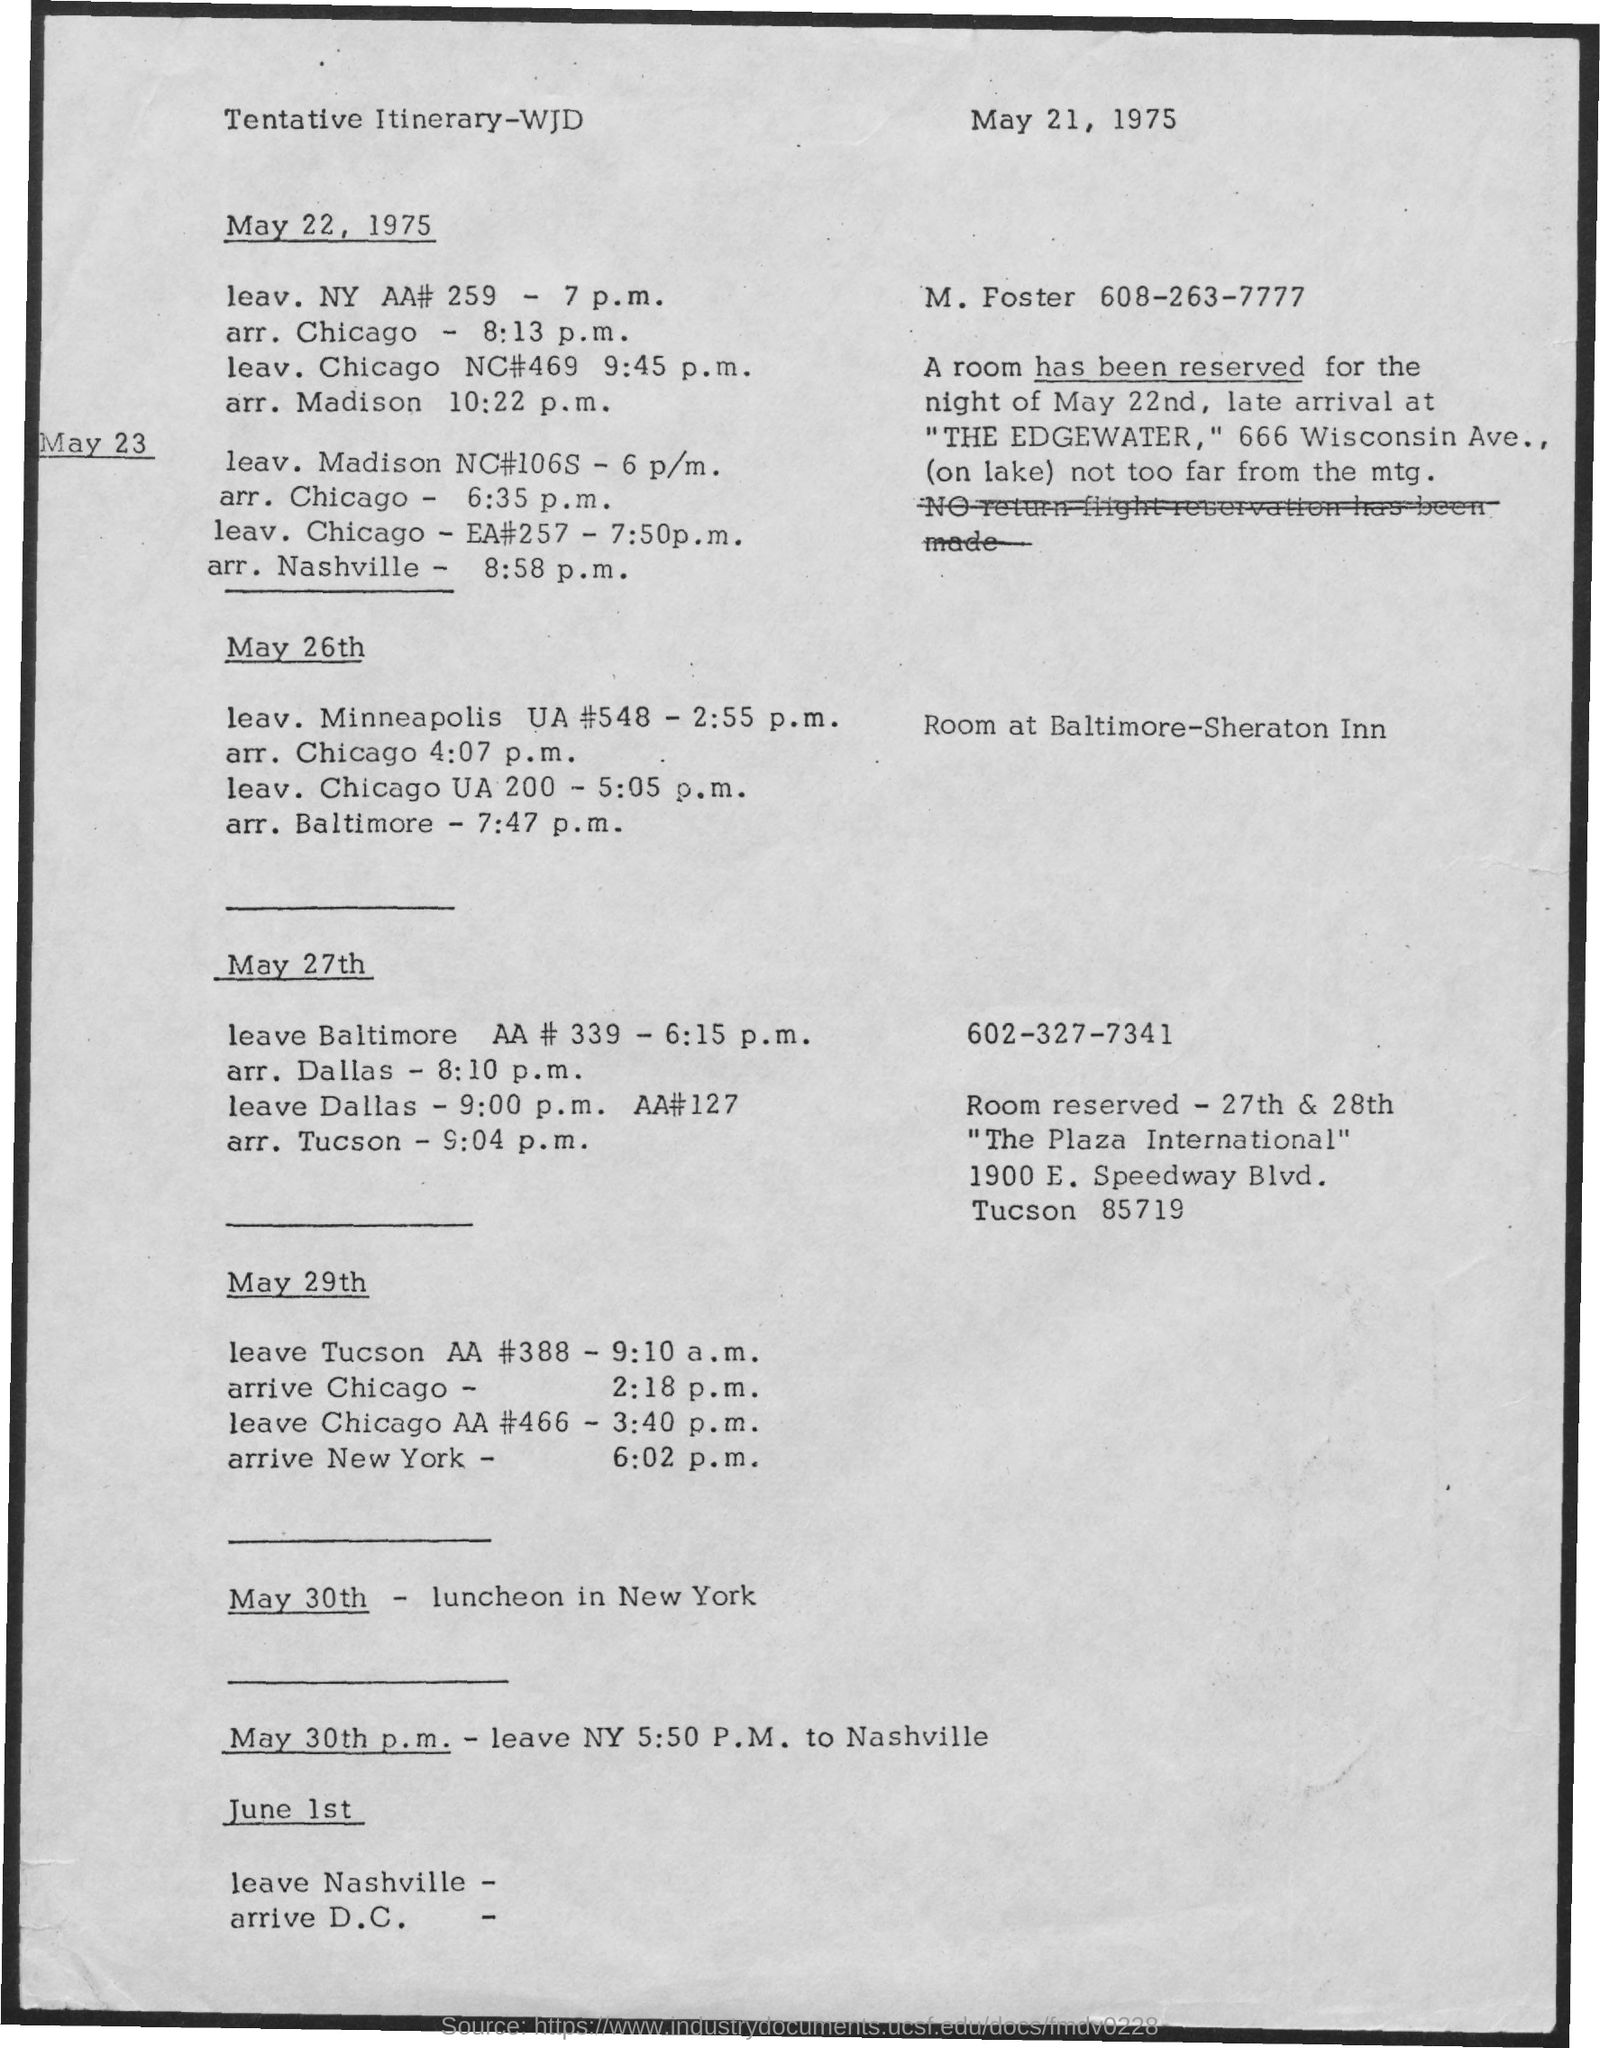When is the luncheon in New York?
Ensure brevity in your answer.  May 30th. 